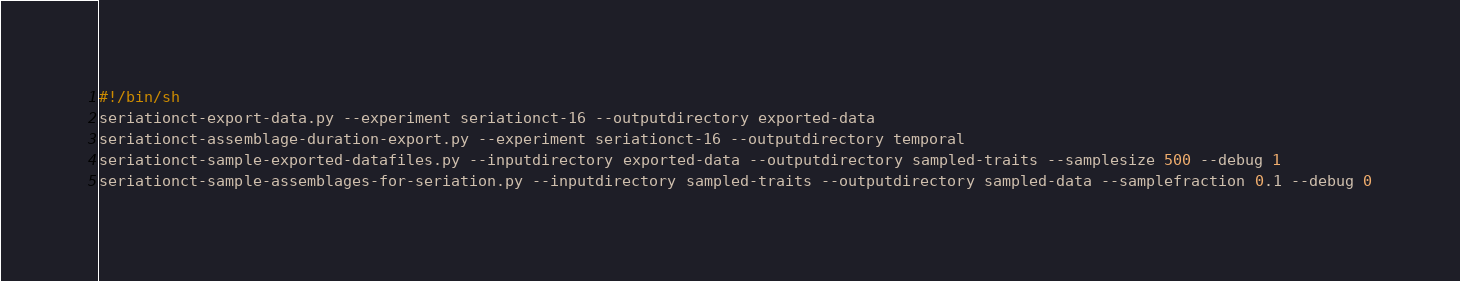<code> <loc_0><loc_0><loc_500><loc_500><_Bash_>#!/bin/sh
seriationct-export-data.py --experiment seriationct-16 --outputdirectory exported-data
seriationct-assemblage-duration-export.py --experiment seriationct-16 --outputdirectory temporal
seriationct-sample-exported-datafiles.py --inputdirectory exported-data --outputdirectory sampled-traits --samplesize 500 --debug 1
seriationct-sample-assemblages-for-seriation.py --inputdirectory sampled-traits --outputdirectory sampled-data --samplefraction 0.1 --debug 0

</code> 